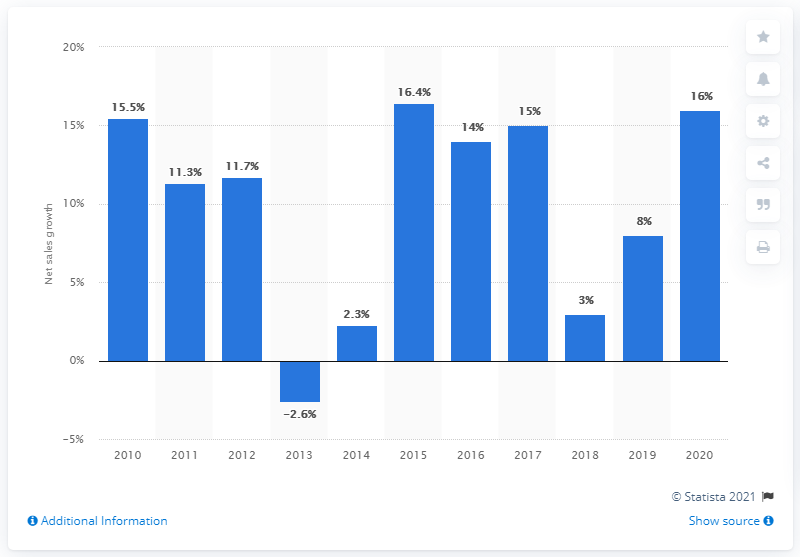Give some essential details in this illustration. The net sales of the adidas Group grew by 15% in 2020. 